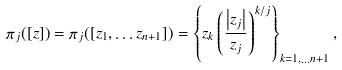Convert formula to latex. <formula><loc_0><loc_0><loc_500><loc_500>\pi _ { j } ( [ z ] ) = \pi _ { j } ( [ z _ { 1 } , \dots z _ { n + 1 } ] ) = \left \{ z _ { k } \left ( \frac { \left | z _ { j } \right | } { z _ { j } } \right ) ^ { k / j } \right \} _ { k = 1 , \dots n + 1 } ,</formula> 